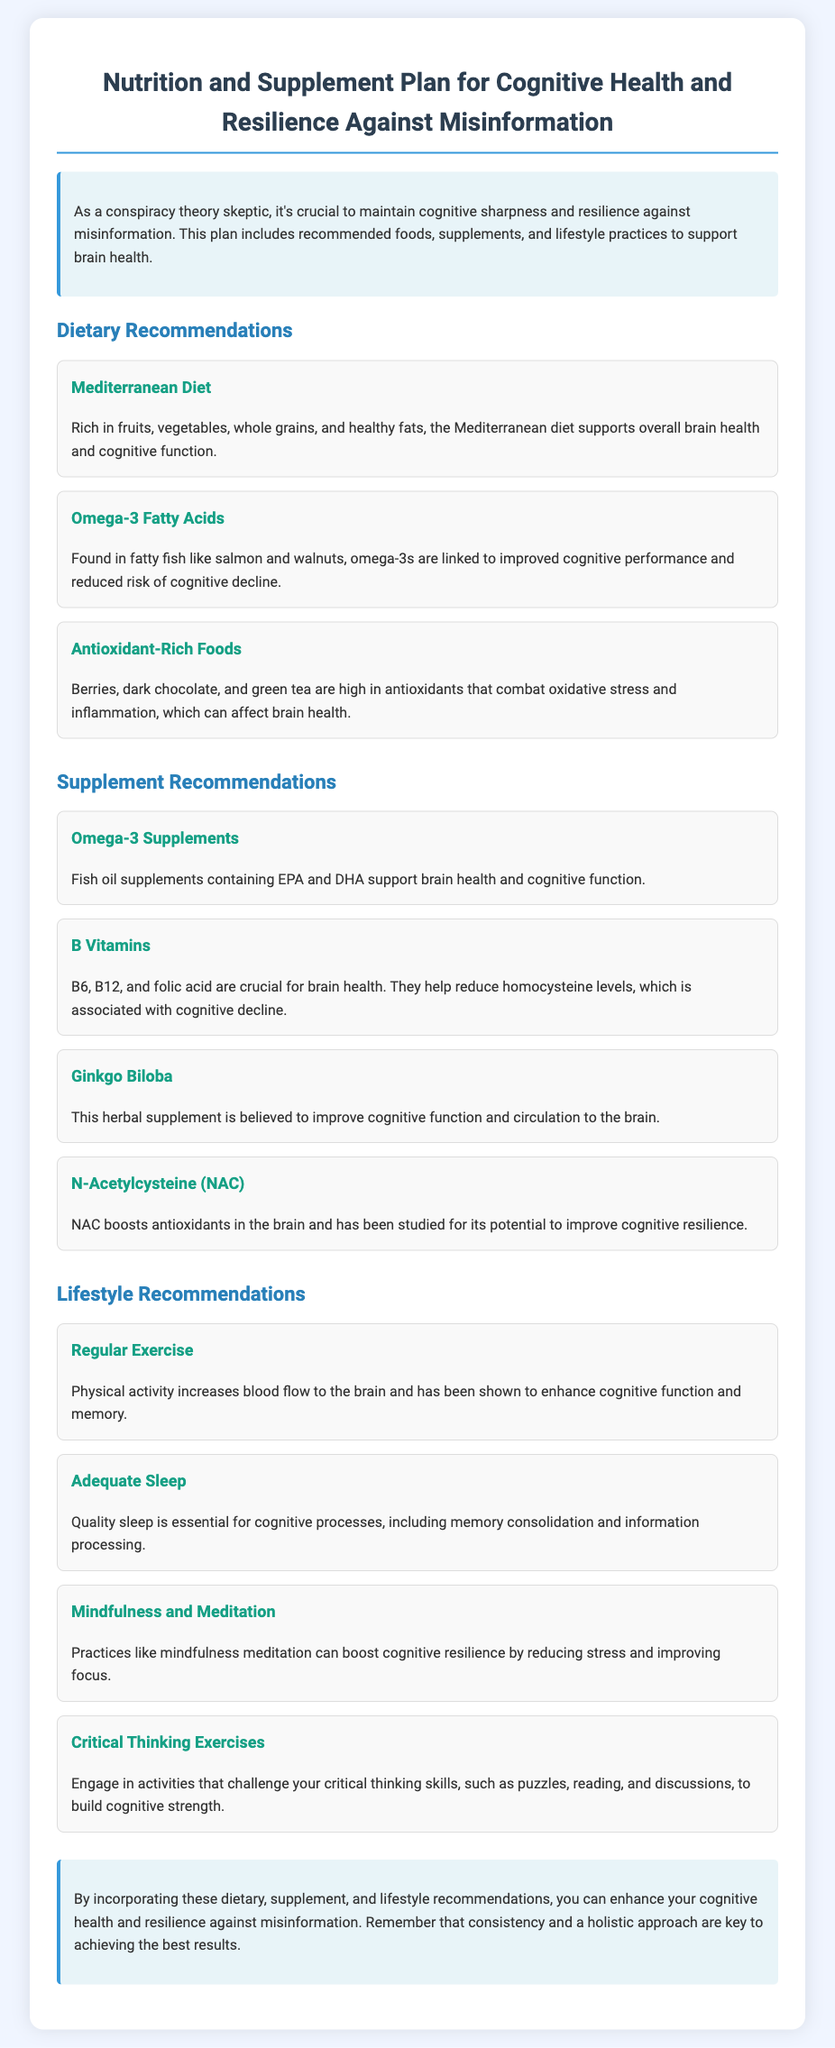what is the primary focus of the plan? The introduction states that the plan is designed to support cognitive health and resilience against misinformation.
Answer: cognitive health and resilience against misinformation which diet is recommended in the document? The section on Dietary Recommendations lists the Mediterranean diet as a recommended diet.
Answer: Mediterranean Diet name one source of Omega-3 fatty acids mentioned. The Dietary Recommendations state that fatty fish like salmon are a source of Omega-3 fatty acids.
Answer: salmon what supplement is believed to improve circulation to the brain? The Supplement Recommendations mention Ginkgo Biloba as improving circulation to the brain.
Answer: Ginkgo Biloba how many B vitamins are mentioned in the document? The Supplement Recommendations list three B vitamins: B6, B12, and folic acid.
Answer: three what practice can boost cognitive resilience according to the lifestyle section? The Lifestyle Recommendations include mindfulness and meditation as practices that boost cognitive resilience.
Answer: mindfulness and meditation what is essential for cognitive processes mentioned? The Lifestyle Recommendations indicate that adequate sleep is essential for cognitive processes.
Answer: adequate sleep which type of diet is associated with improved cognitive performance? The Dietary Recommendations state that the Mediterranean diet supports overall brain health and cognitive function.
Answer: Mediterranean diet how many lifestyle recommendations are provided in total? There are four lifestyle recommendations listed in the document.
Answer: four 